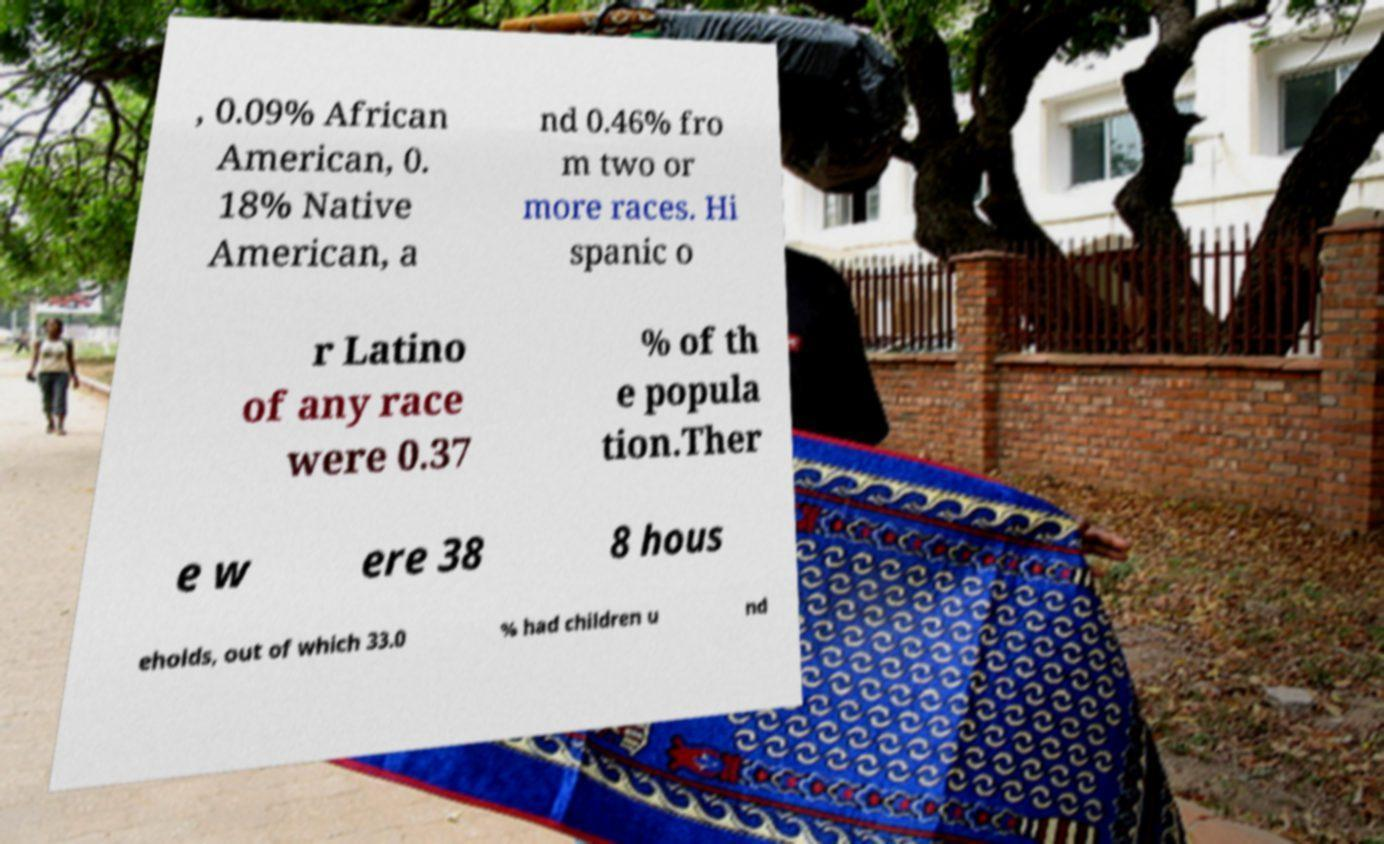Please read and relay the text visible in this image. What does it say? , 0.09% African American, 0. 18% Native American, a nd 0.46% fro m two or more races. Hi spanic o r Latino of any race were 0.37 % of th e popula tion.Ther e w ere 38 8 hous eholds, out of which 33.0 % had children u nd 